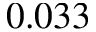<formula> <loc_0><loc_0><loc_500><loc_500>0 . 0 3 3</formula> 